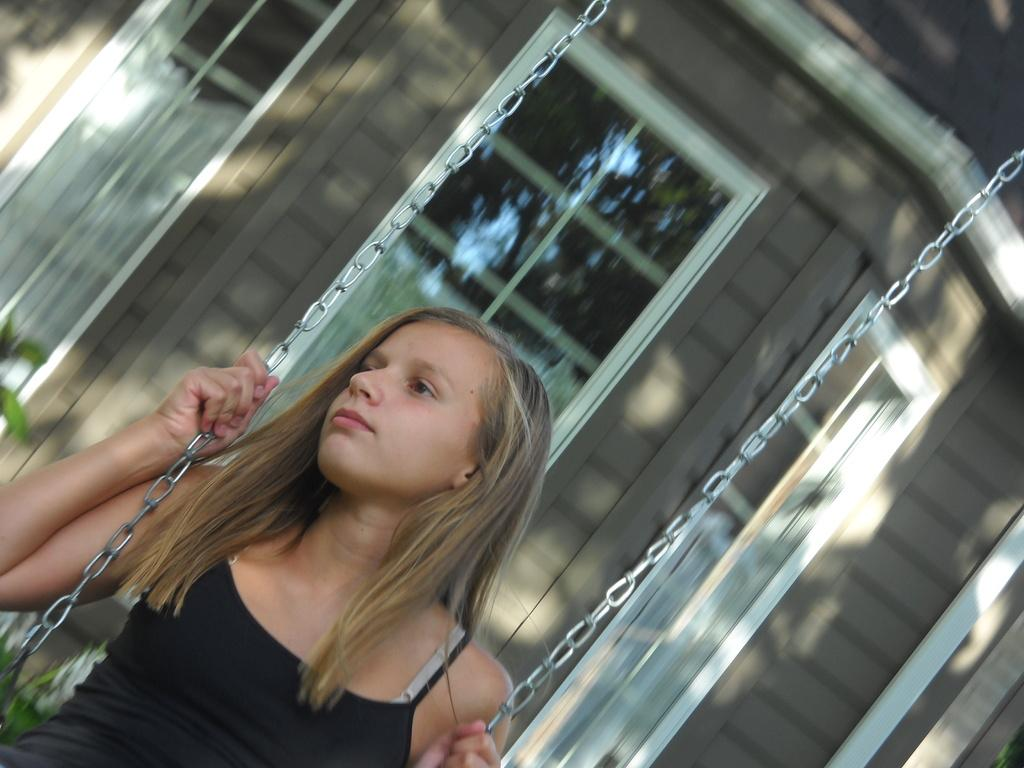Who is the main subject in the image? There is a girl in the image. What is the girl wearing? The girl is wearing a black dress. What can be seen in the background of the image? There is a house in the background of the image. What flavor of linen can be seen in the image? There is no linen present in the image, and therefore no flavor can be associated with it. 